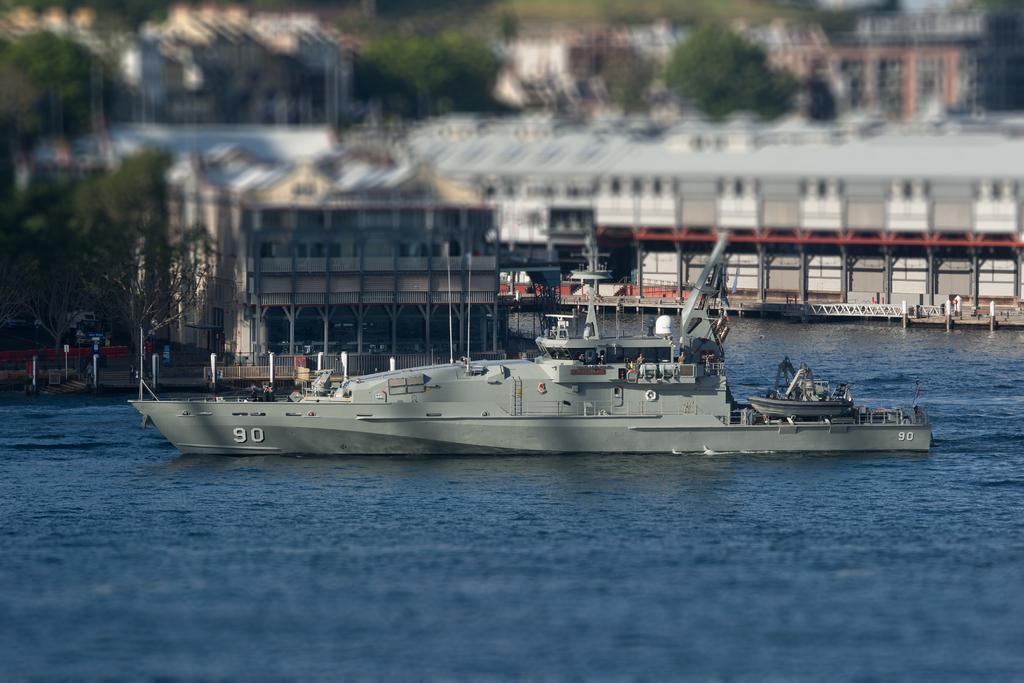Could you give a brief overview of what you see in this image? In this image there is a memo on a river, in the background there are trees, houses and it is blurred. 